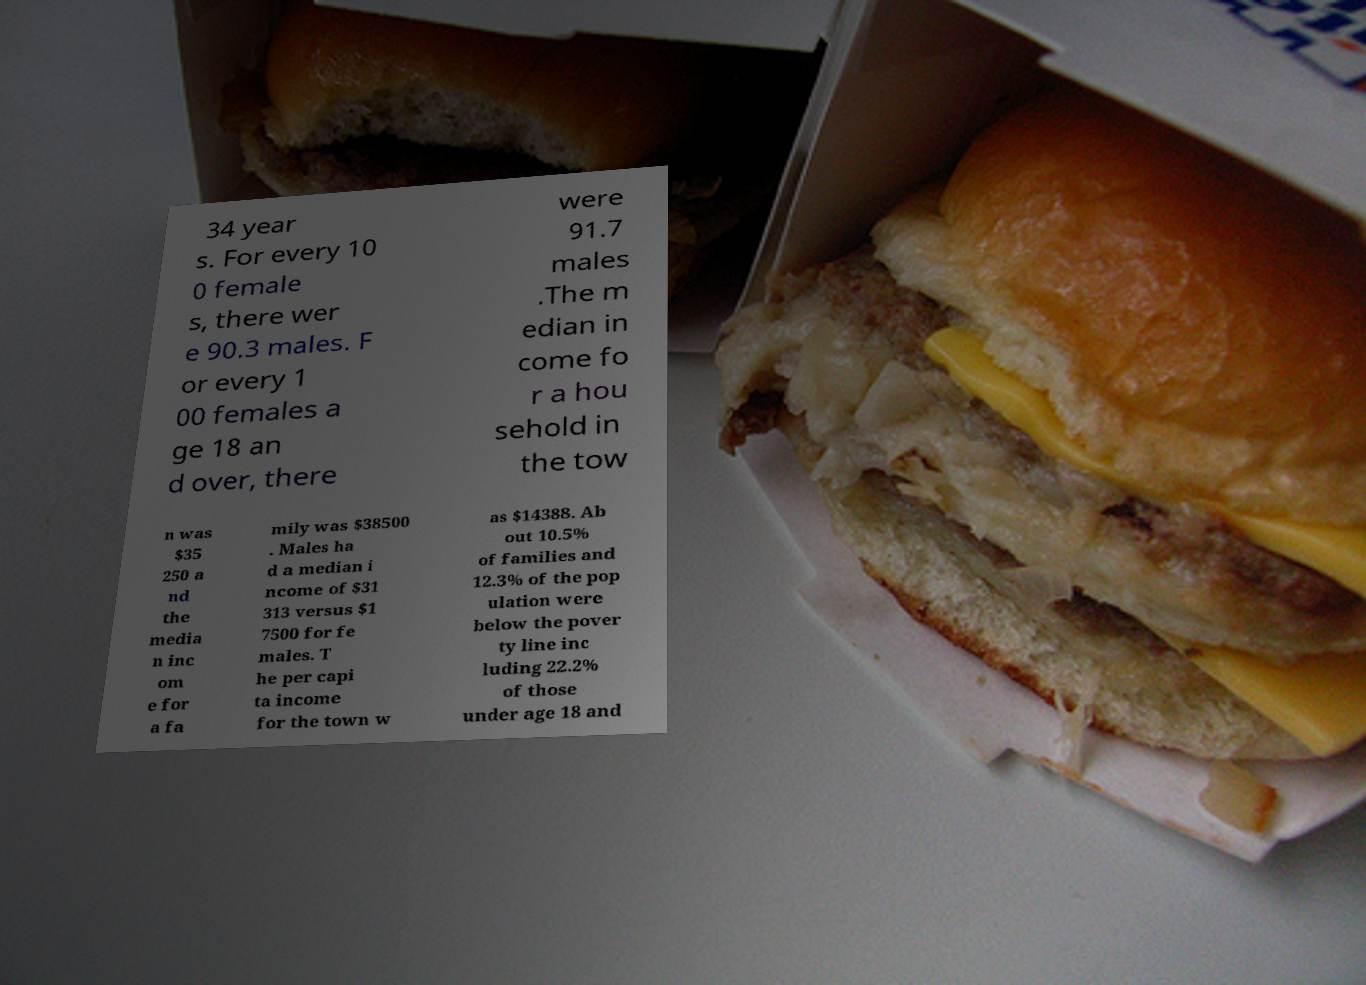Please read and relay the text visible in this image. What does it say? 34 year s. For every 10 0 female s, there wer e 90.3 males. F or every 1 00 females a ge 18 an d over, there were 91.7 males .The m edian in come fo r a hou sehold in the tow n was $35 250 a nd the media n inc om e for a fa mily was $38500 . Males ha d a median i ncome of $31 313 versus $1 7500 for fe males. T he per capi ta income for the town w as $14388. Ab out 10.5% of families and 12.3% of the pop ulation were below the pover ty line inc luding 22.2% of those under age 18 and 